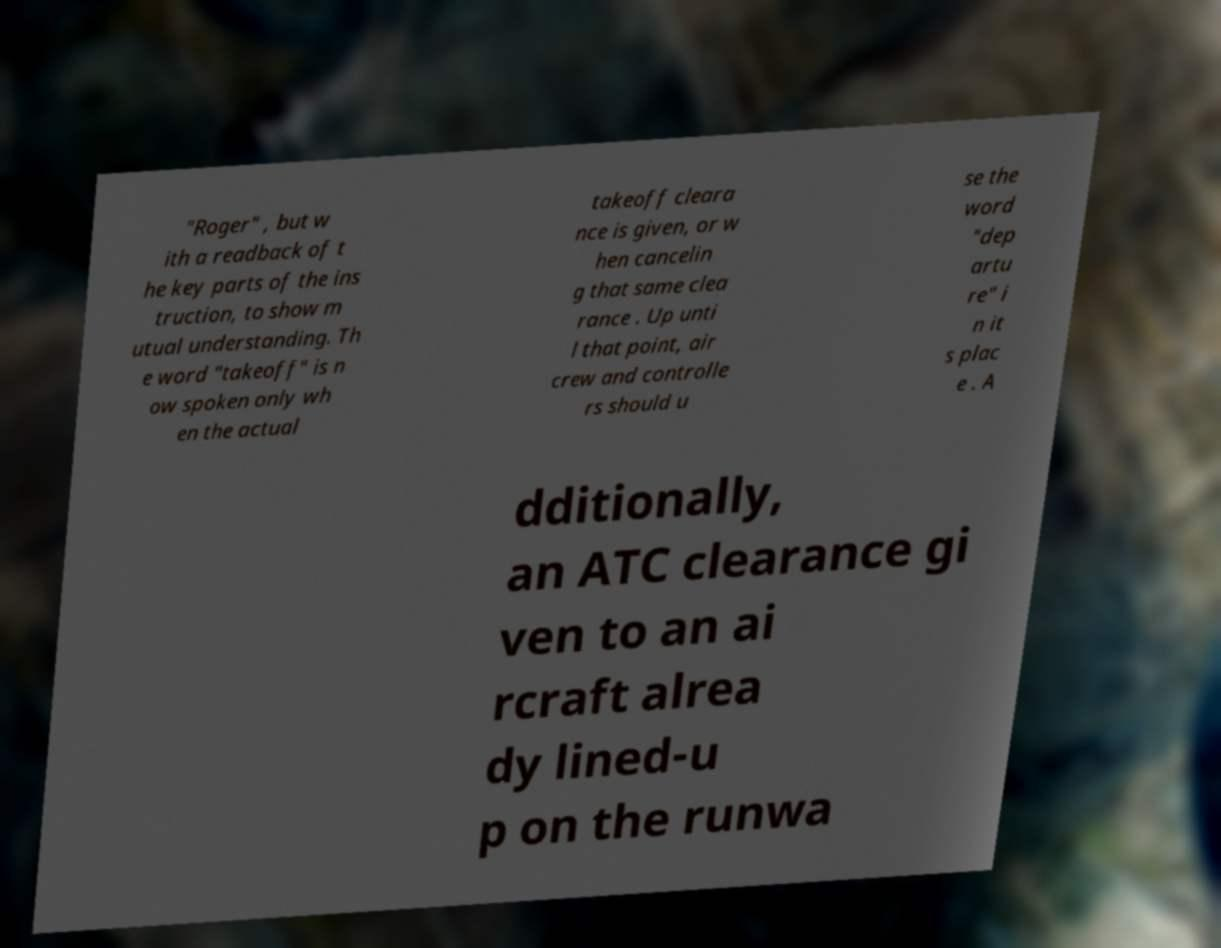Could you assist in decoding the text presented in this image and type it out clearly? "Roger" , but w ith a readback of t he key parts of the ins truction, to show m utual understanding. Th e word "takeoff" is n ow spoken only wh en the actual takeoff cleara nce is given, or w hen cancelin g that same clea rance . Up unti l that point, air crew and controlle rs should u se the word "dep artu re" i n it s plac e . A dditionally, an ATC clearance gi ven to an ai rcraft alrea dy lined-u p on the runwa 